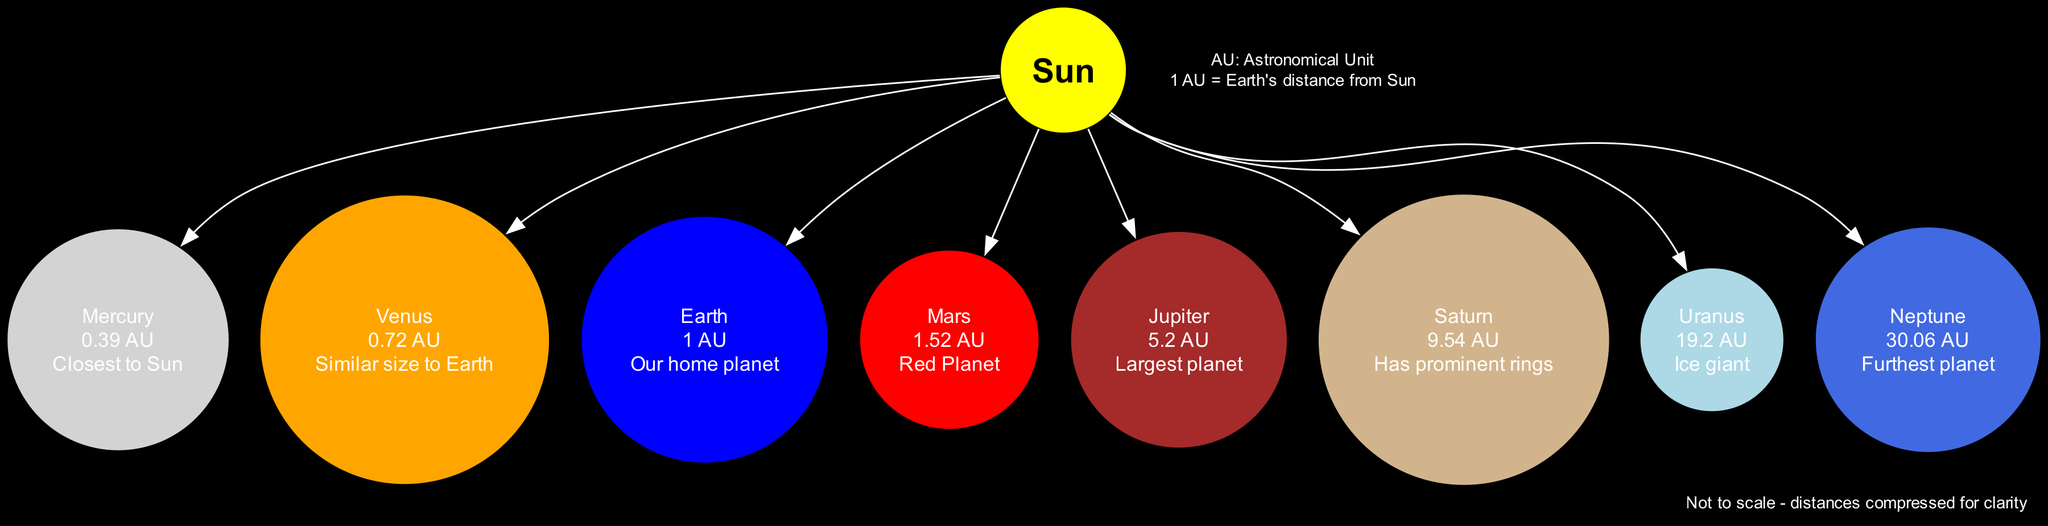What is the distance of Jupiter from the Sun? The diagram lists Jupiter's distance as "5.2 AU", which is stated next to the planet's name.
Answer: 5.2 AU How many planets are closer to the Sun than Earth? By examining the distances, we see that Mercury (0.39 AU) and Venus (0.72 AU) are both closer to the Sun than Earth (1 AU), making a total of two planets.
Answer: 2 Which planet is known as the "Red Planet"? The note associated with Mars in the diagram specifies that it is referred to as the "Red Planet".
Answer: Mars What is the furthest planet from the Sun? Looking at the distances, Neptune is listed as having the greatest distance at "30.06 AU", making it the furthest planet from the Sun.
Answer: Neptune Which planet has prominent rings? The diagram notes that Saturn is characterized by having prominent rings, making it easily identifiable in the diagram.
Answer: Saturn How many total nodes are represented in the diagram? The diagram includes one central node (the Sun) and eight planet nodes, resulting in a total of nine nodes represented.
Answer: 9 What color represents Neptune in the diagram? The color coding of planets shows that Neptune is represented in royal blue, as indicated by its corresponding node color.
Answer: Royal blue Which planet is similar in size to Earth? The diagram specifically states that Venus is similar in size to Earth, noted in its details next to the planet.
Answer: Venus How many Astronomical Units (AU) is the distance from Earth to the Sun? The distance defined for Earth is "1 AU", which is its direct distance from the Sun.
Answer: 1 AU 